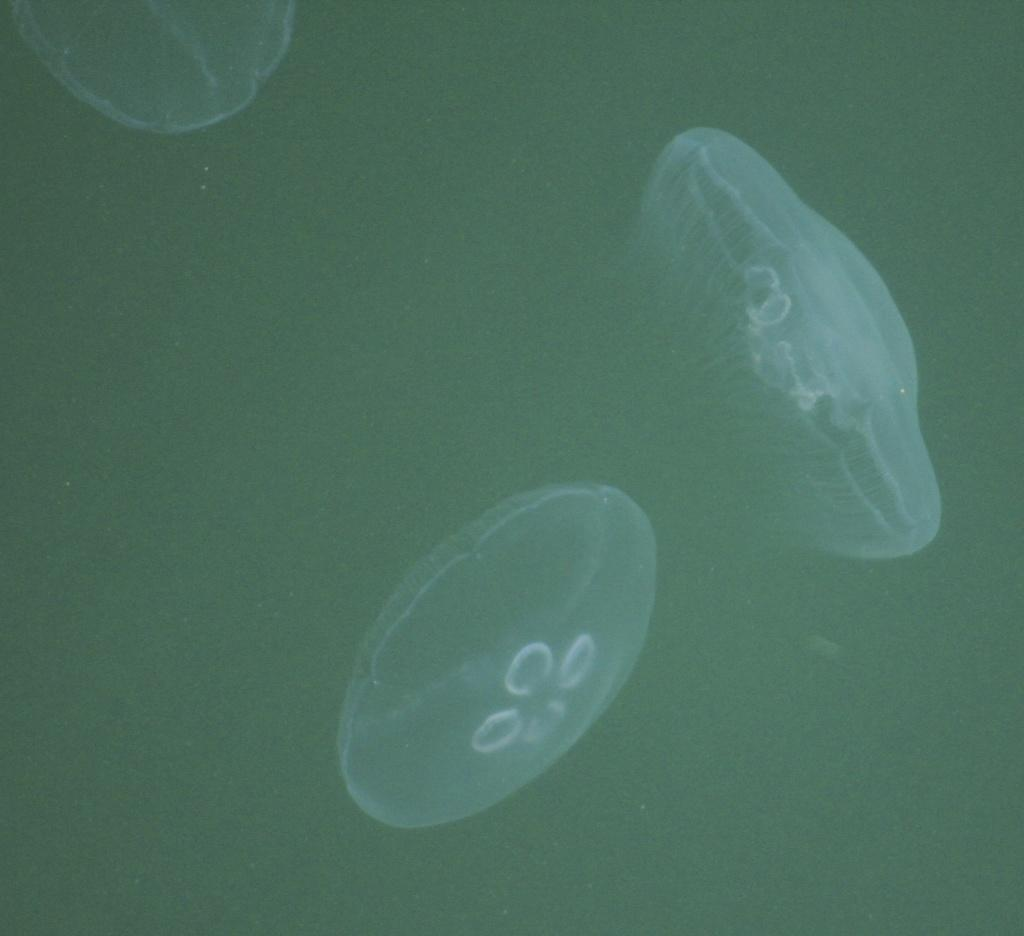What creatures are present in the image? There are three jellyfish in the image. What is the color of the background in the image? The background of the image is dark. What type of lettuce can be seen in the image? There is no lettuce present in the image; it features three jellyfish against a dark background. 